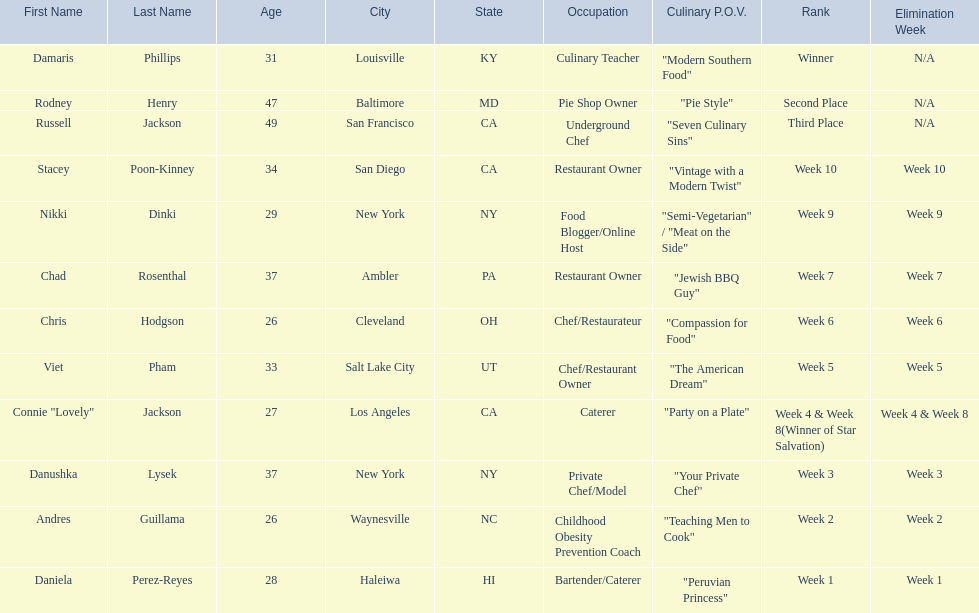Who where the people in the food network? Damaris Phillips, Rodney Henry, Russell Jackson, Stacey Poon-Kinney, Nikki Dinki, Chad Rosenthal, Chris Hodgson, Viet Pham, Connie "Lovely" Jackson, Danushka Lysek, Andres Guillama, Daniela Perez-Reyes. When was nikki dinki eliminated? Week 9. When was viet pham eliminated? Week 5. Which of these two is earlier? Week 5. Who was eliminated in this week? Viet Pham. 